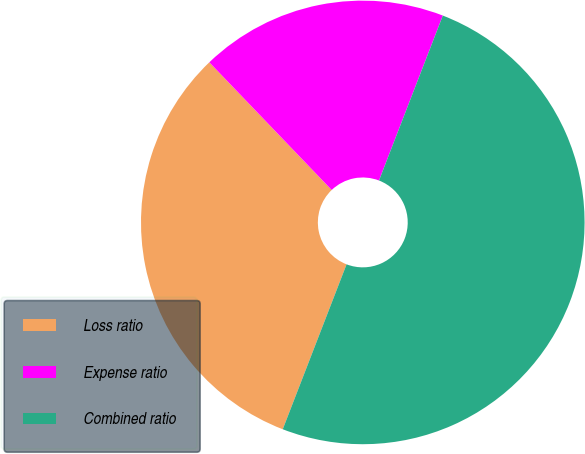Convert chart to OTSL. <chart><loc_0><loc_0><loc_500><loc_500><pie_chart><fcel>Loss ratio<fcel>Expense ratio<fcel>Combined ratio<nl><fcel>31.96%<fcel>18.04%<fcel>50.0%<nl></chart> 